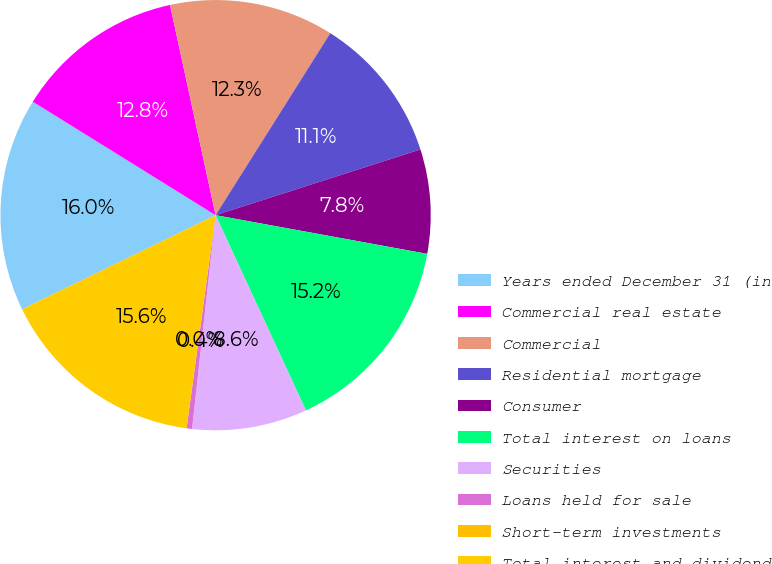<chart> <loc_0><loc_0><loc_500><loc_500><pie_chart><fcel>Years ended December 31 (in<fcel>Commercial real estate<fcel>Commercial<fcel>Residential mortgage<fcel>Consumer<fcel>Total interest on loans<fcel>Securities<fcel>Loans held for sale<fcel>Short-term investments<fcel>Total interest and dividend<nl><fcel>16.05%<fcel>12.76%<fcel>12.35%<fcel>11.11%<fcel>7.82%<fcel>15.23%<fcel>8.64%<fcel>0.41%<fcel>0.0%<fcel>15.64%<nl></chart> 